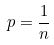<formula> <loc_0><loc_0><loc_500><loc_500>p = \frac { 1 } { n }</formula> 